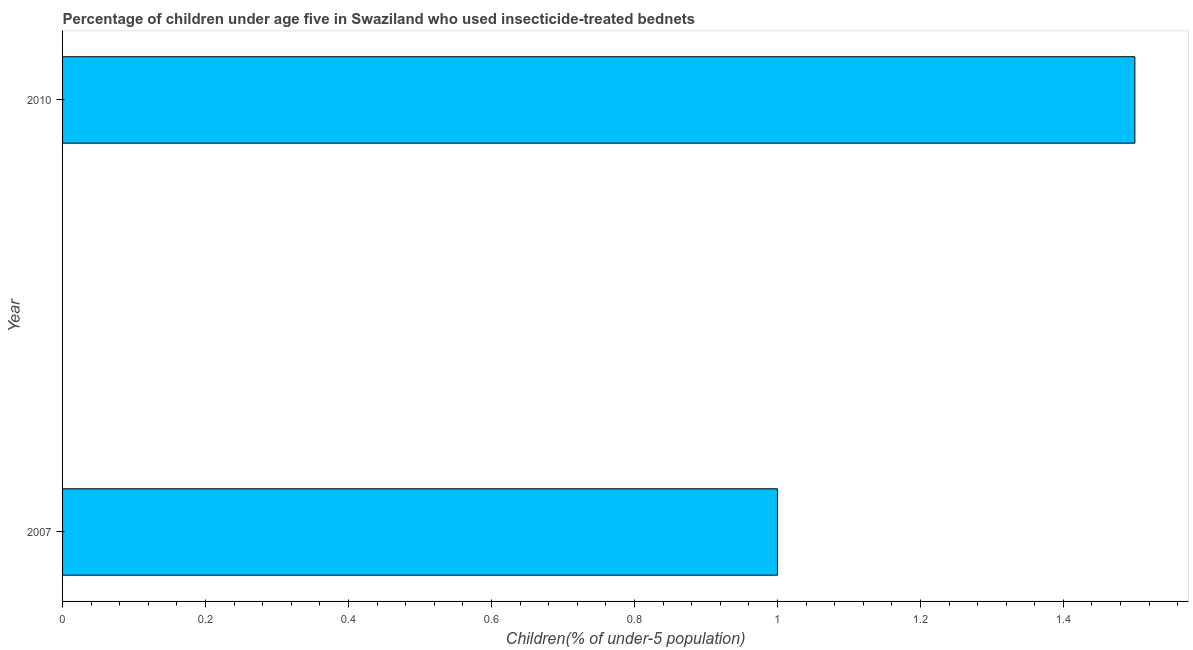Does the graph contain any zero values?
Keep it short and to the point. No. Does the graph contain grids?
Your answer should be very brief. No. What is the title of the graph?
Keep it short and to the point. Percentage of children under age five in Swaziland who used insecticide-treated bednets. What is the label or title of the X-axis?
Your answer should be compact. Children(% of under-5 population). Across all years, what is the minimum percentage of children who use of insecticide-treated bed nets?
Make the answer very short. 1. What is the difference between the percentage of children who use of insecticide-treated bed nets in 2007 and 2010?
Give a very brief answer. -0.5. What is the average percentage of children who use of insecticide-treated bed nets per year?
Offer a very short reply. 1.25. What is the ratio of the percentage of children who use of insecticide-treated bed nets in 2007 to that in 2010?
Your answer should be compact. 0.67. In how many years, is the percentage of children who use of insecticide-treated bed nets greater than the average percentage of children who use of insecticide-treated bed nets taken over all years?
Ensure brevity in your answer.  1. How many bars are there?
Offer a terse response. 2. Are the values on the major ticks of X-axis written in scientific E-notation?
Give a very brief answer. No. What is the Children(% of under-5 population) of 2007?
Provide a succinct answer. 1. What is the difference between the Children(% of under-5 population) in 2007 and 2010?
Your answer should be very brief. -0.5. What is the ratio of the Children(% of under-5 population) in 2007 to that in 2010?
Provide a short and direct response. 0.67. 